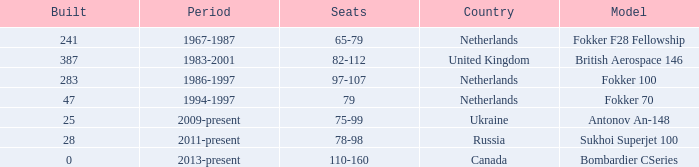Between which years were there 241 fokker 70 model cabins built? 1994-1997. 